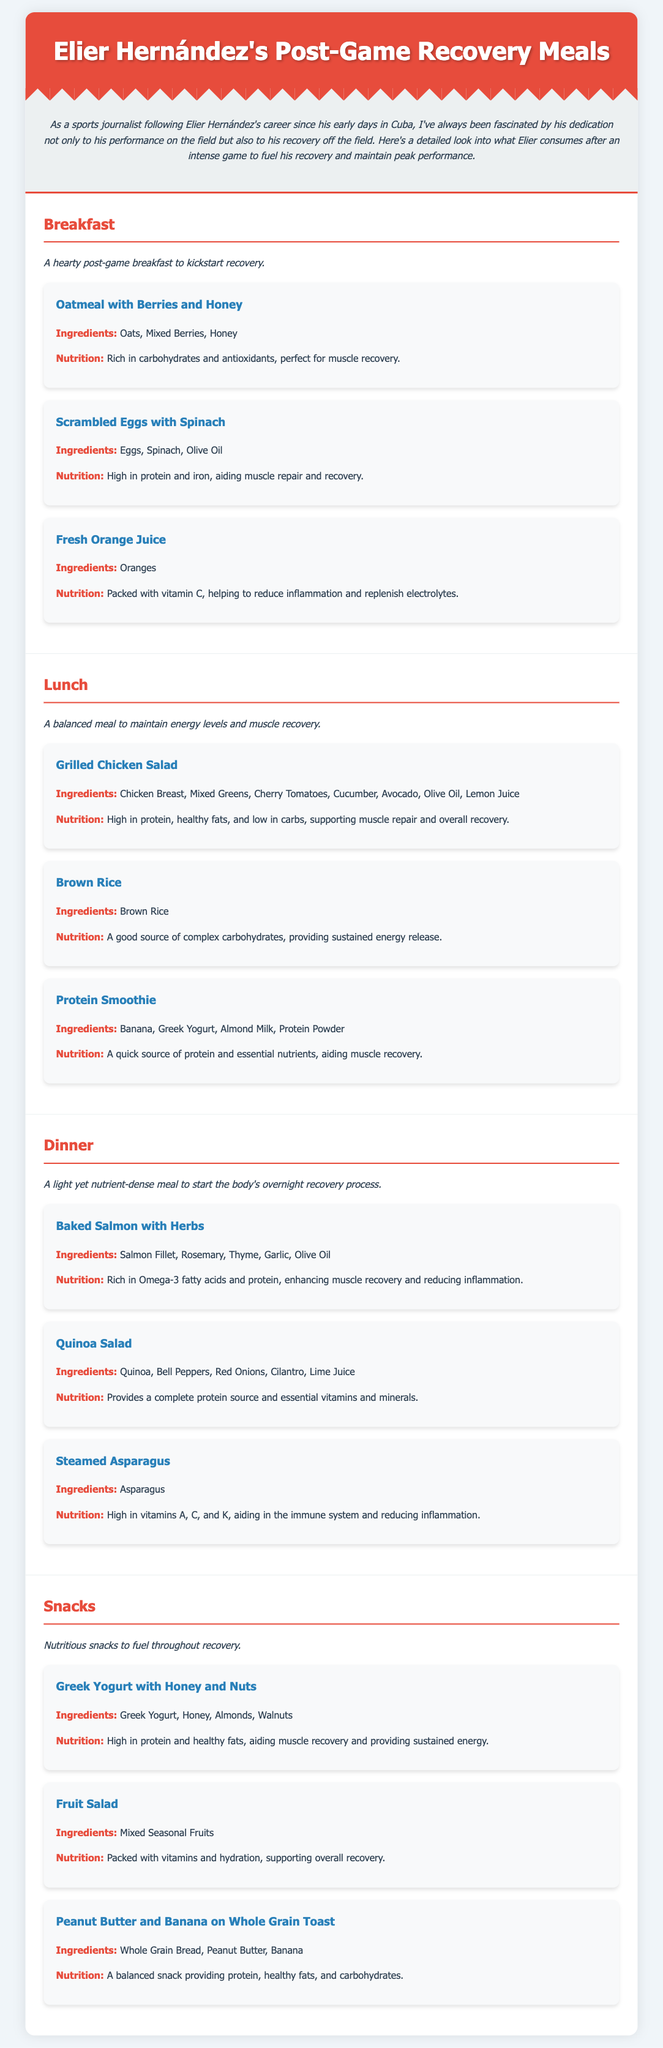What are the main ingredients in the oatmeal dish? The ingredients listed for the oatmeal dish are Oats, Mixed Berries, and Honey.
Answer: Oats, Mixed Berries, Honey What type of protein is included in Elier's post-game breakfast? Scrambled Eggs with Spinach is one of the breakfast items, which is high in protein.
Answer: Eggs What is the nutrition benefit of Fresh Orange Juice? The document states that Fresh Orange Juice is packed with vitamin C, helping to reduce inflammation and replenish electrolytes.
Answer: Vitamin C What is Elier's dinner option that is rich in Omega-3 fatty acids? The meal item Baked Salmon with Herbs is mentioned as rich in Omega-3 fatty acids.
Answer: Baked Salmon How many snacks are listed in the meal plan? The document describes three snack options: Greek Yogurt with Honey and Nuts, Fruit Salad, and Peanut Butter and Banana on Whole Grain Toast.
Answer: Three What is the primary focus of the lunch meals? The lunch meals aim to maintain energy levels and support muscle recovery.
Answer: Energy levels and muscle recovery What type of salad is made for lunch? The lunch includes a Grilled Chicken Salad featuring several ingredients.
Answer: Grilled Chicken Salad What type of carbohydrate is Brown Rice categorized as? It is classified in the document as a good source of complex carbohydrates.
Answer: Complex carbohydrates 